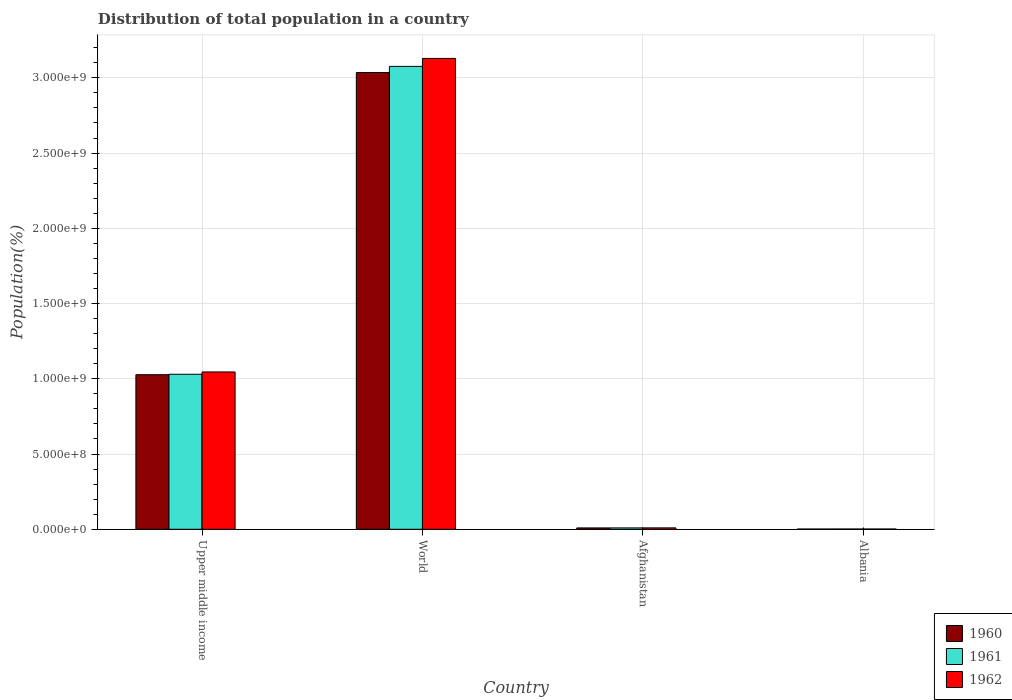How many different coloured bars are there?
Provide a short and direct response. 3. Are the number of bars per tick equal to the number of legend labels?
Offer a terse response. Yes. Are the number of bars on each tick of the X-axis equal?
Keep it short and to the point. Yes. How many bars are there on the 3rd tick from the left?
Your answer should be compact. 3. How many bars are there on the 2nd tick from the right?
Provide a succinct answer. 3. What is the label of the 3rd group of bars from the left?
Make the answer very short. Afghanistan. In how many cases, is the number of bars for a given country not equal to the number of legend labels?
Keep it short and to the point. 0. What is the population of in 1960 in World?
Provide a succinct answer. 3.03e+09. Across all countries, what is the maximum population of in 1961?
Offer a terse response. 3.08e+09. Across all countries, what is the minimum population of in 1961?
Your answer should be very brief. 1.66e+06. In which country was the population of in 1961 minimum?
Offer a terse response. Albania. What is the total population of in 1960 in the graph?
Your answer should be compact. 4.07e+09. What is the difference between the population of in 1961 in Afghanistan and that in World?
Keep it short and to the point. -3.07e+09. What is the difference between the population of in 1962 in World and the population of in 1960 in Afghanistan?
Offer a terse response. 3.12e+09. What is the average population of in 1962 per country?
Offer a terse response. 1.05e+09. What is the difference between the population of of/in 1962 and population of of/in 1960 in Afghanistan?
Offer a terse response. 3.49e+05. In how many countries, is the population of in 1961 greater than 500000000 %?
Make the answer very short. 2. What is the ratio of the population of in 1960 in Upper middle income to that in World?
Make the answer very short. 0.34. Is the difference between the population of in 1962 in Afghanistan and Albania greater than the difference between the population of in 1960 in Afghanistan and Albania?
Your answer should be very brief. Yes. What is the difference between the highest and the second highest population of in 1962?
Your answer should be compact. 3.12e+09. What is the difference between the highest and the lowest population of in 1962?
Keep it short and to the point. 3.13e+09. Is it the case that in every country, the sum of the population of in 1962 and population of in 1961 is greater than the population of in 1960?
Offer a very short reply. Yes. Are all the bars in the graph horizontal?
Keep it short and to the point. No. How many countries are there in the graph?
Your answer should be very brief. 4. What is the difference between two consecutive major ticks on the Y-axis?
Provide a short and direct response. 5.00e+08. Does the graph contain any zero values?
Make the answer very short. No. Where does the legend appear in the graph?
Provide a short and direct response. Bottom right. What is the title of the graph?
Offer a terse response. Distribution of total population in a country. What is the label or title of the X-axis?
Offer a terse response. Country. What is the label or title of the Y-axis?
Provide a short and direct response. Population(%). What is the Population(%) in 1960 in Upper middle income?
Offer a terse response. 1.03e+09. What is the Population(%) of 1961 in Upper middle income?
Provide a succinct answer. 1.03e+09. What is the Population(%) of 1962 in Upper middle income?
Provide a succinct answer. 1.05e+09. What is the Population(%) of 1960 in World?
Your response must be concise. 3.03e+09. What is the Population(%) of 1961 in World?
Offer a very short reply. 3.08e+09. What is the Population(%) in 1962 in World?
Make the answer very short. 3.13e+09. What is the Population(%) of 1960 in Afghanistan?
Offer a terse response. 8.99e+06. What is the Population(%) in 1961 in Afghanistan?
Provide a short and direct response. 9.16e+06. What is the Population(%) of 1962 in Afghanistan?
Your response must be concise. 9.34e+06. What is the Population(%) of 1960 in Albania?
Make the answer very short. 1.61e+06. What is the Population(%) of 1961 in Albania?
Give a very brief answer. 1.66e+06. What is the Population(%) in 1962 in Albania?
Your response must be concise. 1.71e+06. Across all countries, what is the maximum Population(%) of 1960?
Make the answer very short. 3.03e+09. Across all countries, what is the maximum Population(%) in 1961?
Your answer should be compact. 3.08e+09. Across all countries, what is the maximum Population(%) of 1962?
Your response must be concise. 3.13e+09. Across all countries, what is the minimum Population(%) of 1960?
Make the answer very short. 1.61e+06. Across all countries, what is the minimum Population(%) of 1961?
Give a very brief answer. 1.66e+06. Across all countries, what is the minimum Population(%) of 1962?
Your answer should be compact. 1.71e+06. What is the total Population(%) of 1960 in the graph?
Your answer should be very brief. 4.07e+09. What is the total Population(%) in 1961 in the graph?
Provide a succinct answer. 4.12e+09. What is the total Population(%) in 1962 in the graph?
Your answer should be compact. 4.19e+09. What is the difference between the Population(%) in 1960 in Upper middle income and that in World?
Give a very brief answer. -2.01e+09. What is the difference between the Population(%) of 1961 in Upper middle income and that in World?
Offer a very short reply. -2.05e+09. What is the difference between the Population(%) of 1962 in Upper middle income and that in World?
Keep it short and to the point. -2.08e+09. What is the difference between the Population(%) of 1960 in Upper middle income and that in Afghanistan?
Ensure brevity in your answer.  1.02e+09. What is the difference between the Population(%) in 1961 in Upper middle income and that in Afghanistan?
Offer a very short reply. 1.02e+09. What is the difference between the Population(%) in 1962 in Upper middle income and that in Afghanistan?
Your response must be concise. 1.04e+09. What is the difference between the Population(%) in 1960 in Upper middle income and that in Albania?
Keep it short and to the point. 1.03e+09. What is the difference between the Population(%) of 1961 in Upper middle income and that in Albania?
Keep it short and to the point. 1.03e+09. What is the difference between the Population(%) of 1962 in Upper middle income and that in Albania?
Your answer should be very brief. 1.04e+09. What is the difference between the Population(%) in 1960 in World and that in Afghanistan?
Offer a very short reply. 3.03e+09. What is the difference between the Population(%) in 1961 in World and that in Afghanistan?
Your answer should be very brief. 3.07e+09. What is the difference between the Population(%) of 1962 in World and that in Afghanistan?
Provide a succinct answer. 3.12e+09. What is the difference between the Population(%) of 1960 in World and that in Albania?
Offer a very short reply. 3.03e+09. What is the difference between the Population(%) in 1961 in World and that in Albania?
Offer a terse response. 3.07e+09. What is the difference between the Population(%) of 1962 in World and that in Albania?
Your response must be concise. 3.13e+09. What is the difference between the Population(%) of 1960 in Afghanistan and that in Albania?
Ensure brevity in your answer.  7.39e+06. What is the difference between the Population(%) of 1961 in Afghanistan and that in Albania?
Ensure brevity in your answer.  7.51e+06. What is the difference between the Population(%) of 1962 in Afghanistan and that in Albania?
Ensure brevity in your answer.  7.63e+06. What is the difference between the Population(%) in 1960 in Upper middle income and the Population(%) in 1961 in World?
Give a very brief answer. -2.05e+09. What is the difference between the Population(%) in 1960 in Upper middle income and the Population(%) in 1962 in World?
Provide a succinct answer. -2.10e+09. What is the difference between the Population(%) of 1961 in Upper middle income and the Population(%) of 1962 in World?
Your response must be concise. -2.10e+09. What is the difference between the Population(%) of 1960 in Upper middle income and the Population(%) of 1961 in Afghanistan?
Make the answer very short. 1.02e+09. What is the difference between the Population(%) of 1960 in Upper middle income and the Population(%) of 1962 in Afghanistan?
Provide a succinct answer. 1.02e+09. What is the difference between the Population(%) of 1961 in Upper middle income and the Population(%) of 1962 in Afghanistan?
Make the answer very short. 1.02e+09. What is the difference between the Population(%) of 1960 in Upper middle income and the Population(%) of 1961 in Albania?
Offer a terse response. 1.03e+09. What is the difference between the Population(%) in 1960 in Upper middle income and the Population(%) in 1962 in Albania?
Your answer should be compact. 1.03e+09. What is the difference between the Population(%) in 1961 in Upper middle income and the Population(%) in 1962 in Albania?
Give a very brief answer. 1.03e+09. What is the difference between the Population(%) in 1960 in World and the Population(%) in 1961 in Afghanistan?
Provide a succinct answer. 3.03e+09. What is the difference between the Population(%) of 1960 in World and the Population(%) of 1962 in Afghanistan?
Offer a terse response. 3.03e+09. What is the difference between the Population(%) of 1961 in World and the Population(%) of 1962 in Afghanistan?
Provide a succinct answer. 3.07e+09. What is the difference between the Population(%) of 1960 in World and the Population(%) of 1961 in Albania?
Keep it short and to the point. 3.03e+09. What is the difference between the Population(%) in 1960 in World and the Population(%) in 1962 in Albania?
Provide a short and direct response. 3.03e+09. What is the difference between the Population(%) of 1961 in World and the Population(%) of 1962 in Albania?
Keep it short and to the point. 3.07e+09. What is the difference between the Population(%) in 1960 in Afghanistan and the Population(%) in 1961 in Albania?
Offer a terse response. 7.33e+06. What is the difference between the Population(%) of 1960 in Afghanistan and the Population(%) of 1962 in Albania?
Offer a very short reply. 7.28e+06. What is the difference between the Population(%) in 1961 in Afghanistan and the Population(%) in 1962 in Albania?
Offer a very short reply. 7.45e+06. What is the average Population(%) of 1960 per country?
Your answer should be very brief. 1.02e+09. What is the average Population(%) of 1961 per country?
Ensure brevity in your answer.  1.03e+09. What is the average Population(%) in 1962 per country?
Make the answer very short. 1.05e+09. What is the difference between the Population(%) in 1960 and Population(%) in 1961 in Upper middle income?
Ensure brevity in your answer.  -2.91e+06. What is the difference between the Population(%) of 1960 and Population(%) of 1962 in Upper middle income?
Offer a very short reply. -1.82e+07. What is the difference between the Population(%) of 1961 and Population(%) of 1962 in Upper middle income?
Provide a short and direct response. -1.53e+07. What is the difference between the Population(%) of 1960 and Population(%) of 1961 in World?
Give a very brief answer. -4.11e+07. What is the difference between the Population(%) of 1960 and Population(%) of 1962 in World?
Provide a succinct answer. -9.40e+07. What is the difference between the Population(%) of 1961 and Population(%) of 1962 in World?
Your answer should be compact. -5.30e+07. What is the difference between the Population(%) in 1960 and Population(%) in 1961 in Afghanistan?
Keep it short and to the point. -1.70e+05. What is the difference between the Population(%) of 1960 and Population(%) of 1962 in Afghanistan?
Offer a terse response. -3.49e+05. What is the difference between the Population(%) in 1961 and Population(%) in 1962 in Afghanistan?
Give a very brief answer. -1.79e+05. What is the difference between the Population(%) of 1960 and Population(%) of 1961 in Albania?
Make the answer very short. -5.10e+04. What is the difference between the Population(%) in 1960 and Population(%) in 1962 in Albania?
Give a very brief answer. -1.03e+05. What is the difference between the Population(%) in 1961 and Population(%) in 1962 in Albania?
Your answer should be compact. -5.15e+04. What is the ratio of the Population(%) in 1960 in Upper middle income to that in World?
Make the answer very short. 0.34. What is the ratio of the Population(%) in 1961 in Upper middle income to that in World?
Keep it short and to the point. 0.33. What is the ratio of the Population(%) in 1962 in Upper middle income to that in World?
Give a very brief answer. 0.33. What is the ratio of the Population(%) in 1960 in Upper middle income to that in Afghanistan?
Make the answer very short. 114.21. What is the ratio of the Population(%) of 1961 in Upper middle income to that in Afghanistan?
Offer a very short reply. 112.4. What is the ratio of the Population(%) in 1962 in Upper middle income to that in Afghanistan?
Your answer should be compact. 111.89. What is the ratio of the Population(%) of 1960 in Upper middle income to that in Albania?
Ensure brevity in your answer.  638.53. What is the ratio of the Population(%) in 1961 in Upper middle income to that in Albania?
Your answer should be compact. 620.67. What is the ratio of the Population(%) of 1962 in Upper middle income to that in Albania?
Keep it short and to the point. 610.92. What is the ratio of the Population(%) in 1960 in World to that in Afghanistan?
Your answer should be compact. 337.41. What is the ratio of the Population(%) in 1961 in World to that in Afghanistan?
Ensure brevity in your answer.  335.63. What is the ratio of the Population(%) of 1962 in World to that in Afghanistan?
Offer a very short reply. 334.87. What is the ratio of the Population(%) of 1960 in World to that in Albania?
Make the answer very short. 1886.48. What is the ratio of the Population(%) of 1961 in World to that in Albania?
Make the answer very short. 1853.26. What is the ratio of the Population(%) of 1962 in World to that in Albania?
Provide a short and direct response. 1828.41. What is the ratio of the Population(%) in 1960 in Afghanistan to that in Albania?
Provide a succinct answer. 5.59. What is the ratio of the Population(%) in 1961 in Afghanistan to that in Albania?
Ensure brevity in your answer.  5.52. What is the ratio of the Population(%) of 1962 in Afghanistan to that in Albania?
Offer a very short reply. 5.46. What is the difference between the highest and the second highest Population(%) in 1960?
Provide a short and direct response. 2.01e+09. What is the difference between the highest and the second highest Population(%) of 1961?
Make the answer very short. 2.05e+09. What is the difference between the highest and the second highest Population(%) in 1962?
Offer a very short reply. 2.08e+09. What is the difference between the highest and the lowest Population(%) of 1960?
Offer a very short reply. 3.03e+09. What is the difference between the highest and the lowest Population(%) of 1961?
Provide a short and direct response. 3.07e+09. What is the difference between the highest and the lowest Population(%) in 1962?
Offer a terse response. 3.13e+09. 